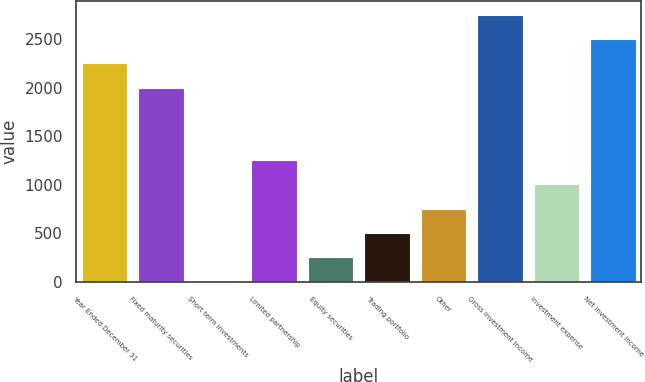Convert chart to OTSL. <chart><loc_0><loc_0><loc_500><loc_500><bar_chart><fcel>Year Ended December 31<fcel>Fixed maturity securities<fcel>Short term investments<fcel>Limited partnership<fcel>Equity securities<fcel>Trading portfolio<fcel>Other<fcel>Gross investment income<fcel>Investment expense<fcel>Net investment income<nl><fcel>2248.3<fcel>1998<fcel>3<fcel>1254.5<fcel>253.3<fcel>503.6<fcel>753.9<fcel>2748.9<fcel>1004.2<fcel>2498.6<nl></chart> 